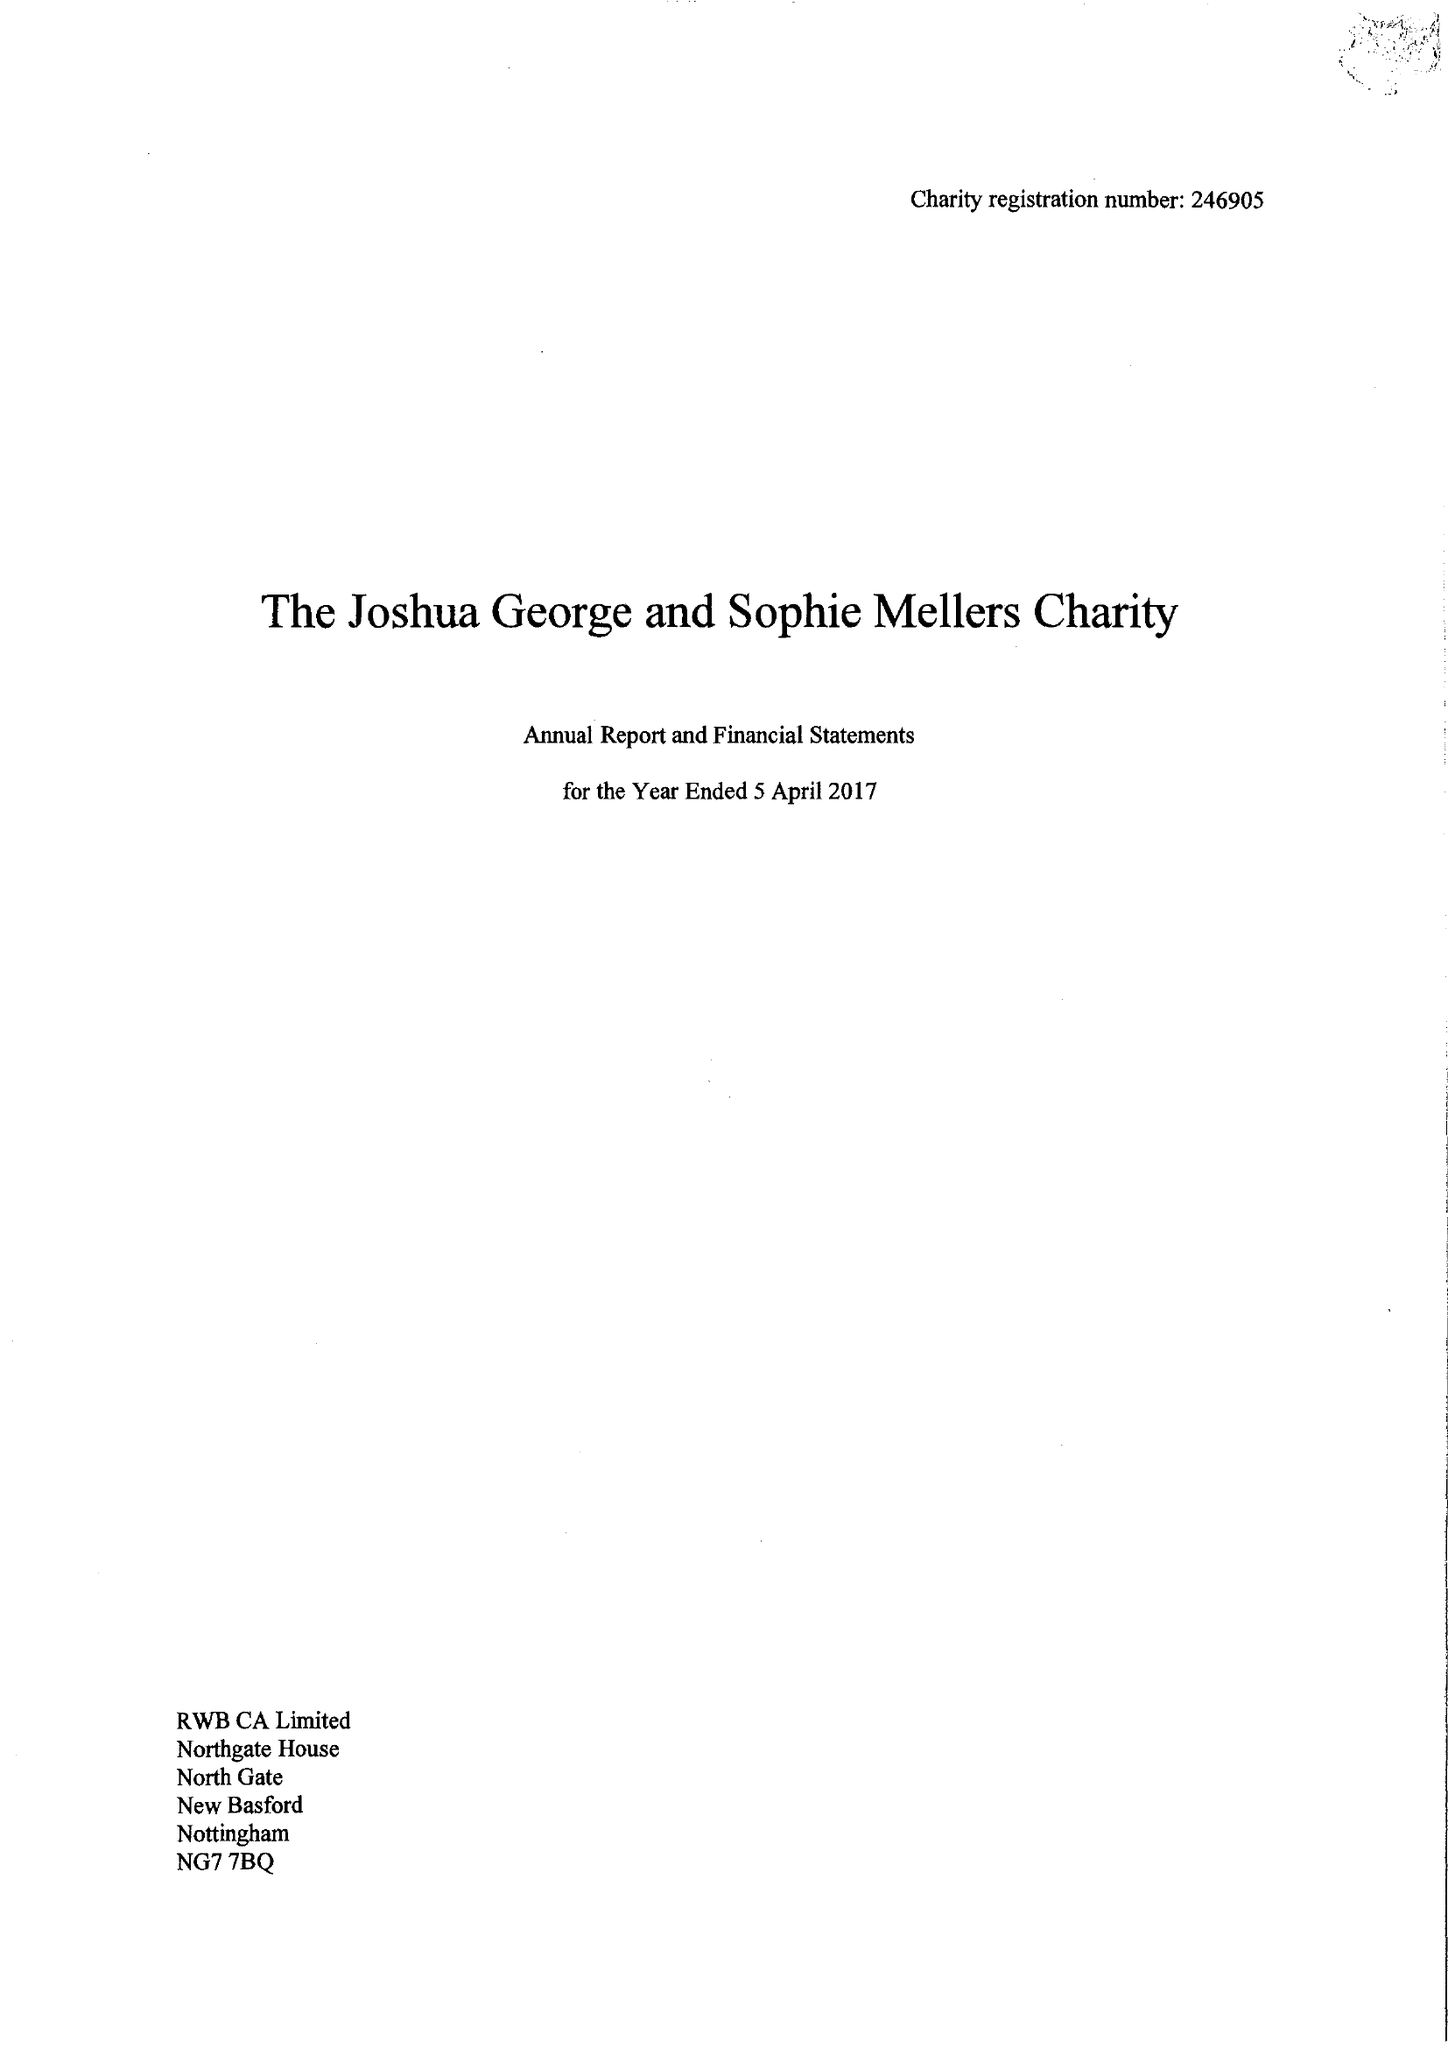What is the value for the income_annually_in_british_pounds?
Answer the question using a single word or phrase. 31566.00 